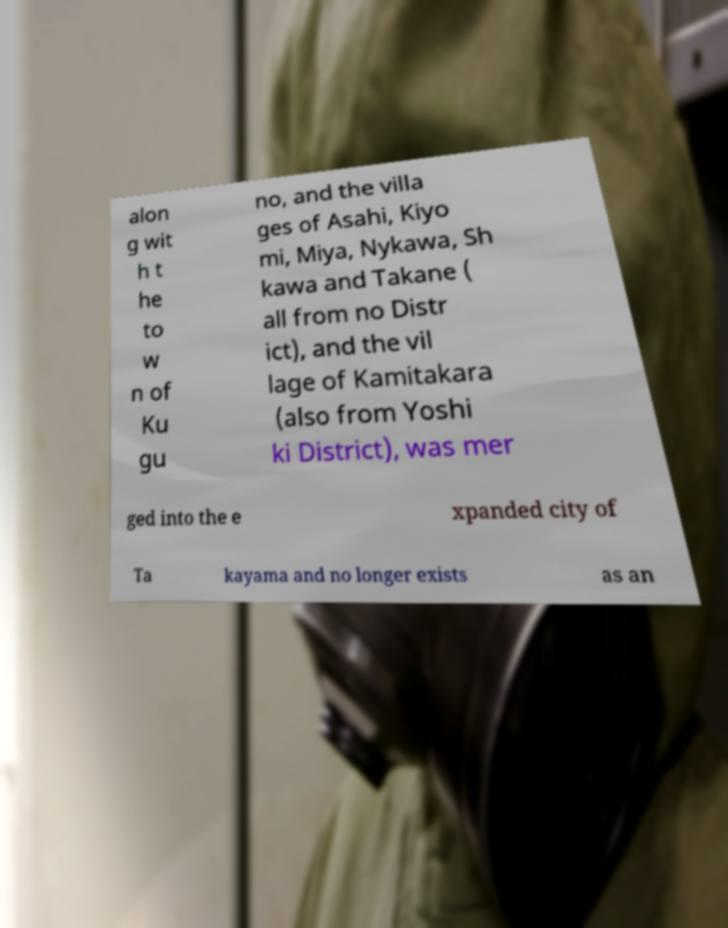Could you assist in decoding the text presented in this image and type it out clearly? alon g wit h t he to w n of Ku gu no, and the villa ges of Asahi, Kiyo mi, Miya, Nykawa, Sh kawa and Takane ( all from no Distr ict), and the vil lage of Kamitakara (also from Yoshi ki District), was mer ged into the e xpanded city of Ta kayama and no longer exists as an 